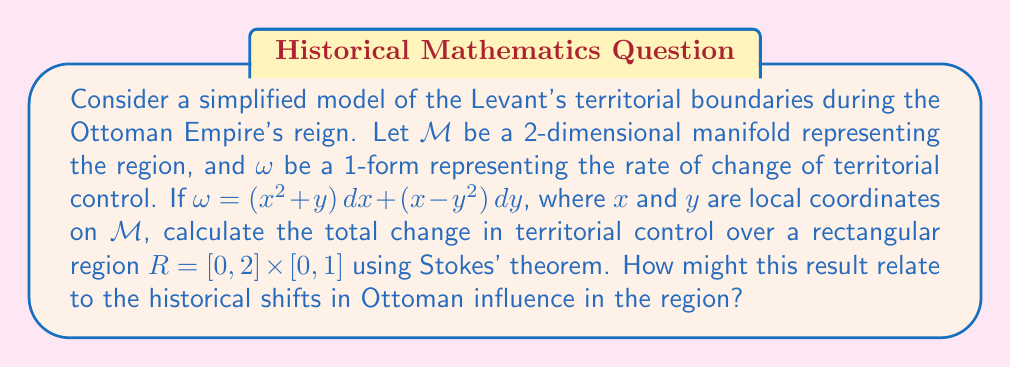Could you help me with this problem? Let's approach this step-by-step:

1) Stokes' theorem states that for a 1-form $\omega$ on a manifold $M$ with boundary $\partial M$:

   $$\int_{\partial M} \omega = \int_M d\omega$$

2) We need to calculate $d\omega$:
   
   $$d\omega = \left(\frac{\partial}{\partial y}(x^2 + y) - \frac{\partial}{\partial x}(x - y^2)\right)dx \wedge dy$$
   $$= (1 - 1)dx \wedge dy = 0$$

3) Since $d\omega = 0$, the integral over $M$ is zero. Therefore, we only need to calculate the line integral over $\partial R$.

4) Parameterize the boundary $\partial R$ counterclockwise:
   - Bottom: $\gamma_1(t) = (t, 0)$, $t \in [0,2]$
   - Right: $\gamma_2(t) = (2, t)$, $t \in [0,1]$
   - Top: $\gamma_3(t) = (2-t, 1)$, $t \in [0,2]$
   - Left: $\gamma_4(t) = (0, 1-t)$, $t \in [0,1]$

5) Calculate the line integral for each side:

   Bottom: $\int_{\gamma_1} \omega = \int_0^2 (t^2)\,dt = \frac{8}{3}$
   
   Right: $\int_{\gamma_2} \omega = \int_0^1 (4 + t + 2 - t^2)\,dt = 6 - \frac{1}{3} = \frac{17}{3}$
   
   Top: $\int_{\gamma_3} \omega = \int_0^2 (-(2-t)^2 - 1)\,dt = -\frac{10}{3}$
   
   Left: $\int_{\gamma_4} \omega = \int_0^1 (-(1-t)^2)\,dt = -\frac{1}{3}$

6) Sum all parts:

   $$\int_{\partial R} \omega = \frac{8}{3} + \frac{17}{3} - \frac{10}{3} - \frac{1}{3} = \frac{14}{3}$$

This result represents the net change in territorial control over the region $R$. The positive value suggests a net increase in control, which could be interpreted as a consolidation of Ottoman power in this part of the Levant during a specific period. However, as a historian skeptical of revolutions, one might argue that this mathematical model oversimplifies the complex socio-political dynamics that shaped Ottoman influence in the region.
Answer: $\frac{14}{3}$ 